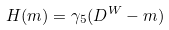Convert formula to latex. <formula><loc_0><loc_0><loc_500><loc_500>H ( m ) = \gamma _ { 5 } ( D ^ { W } - m )</formula> 